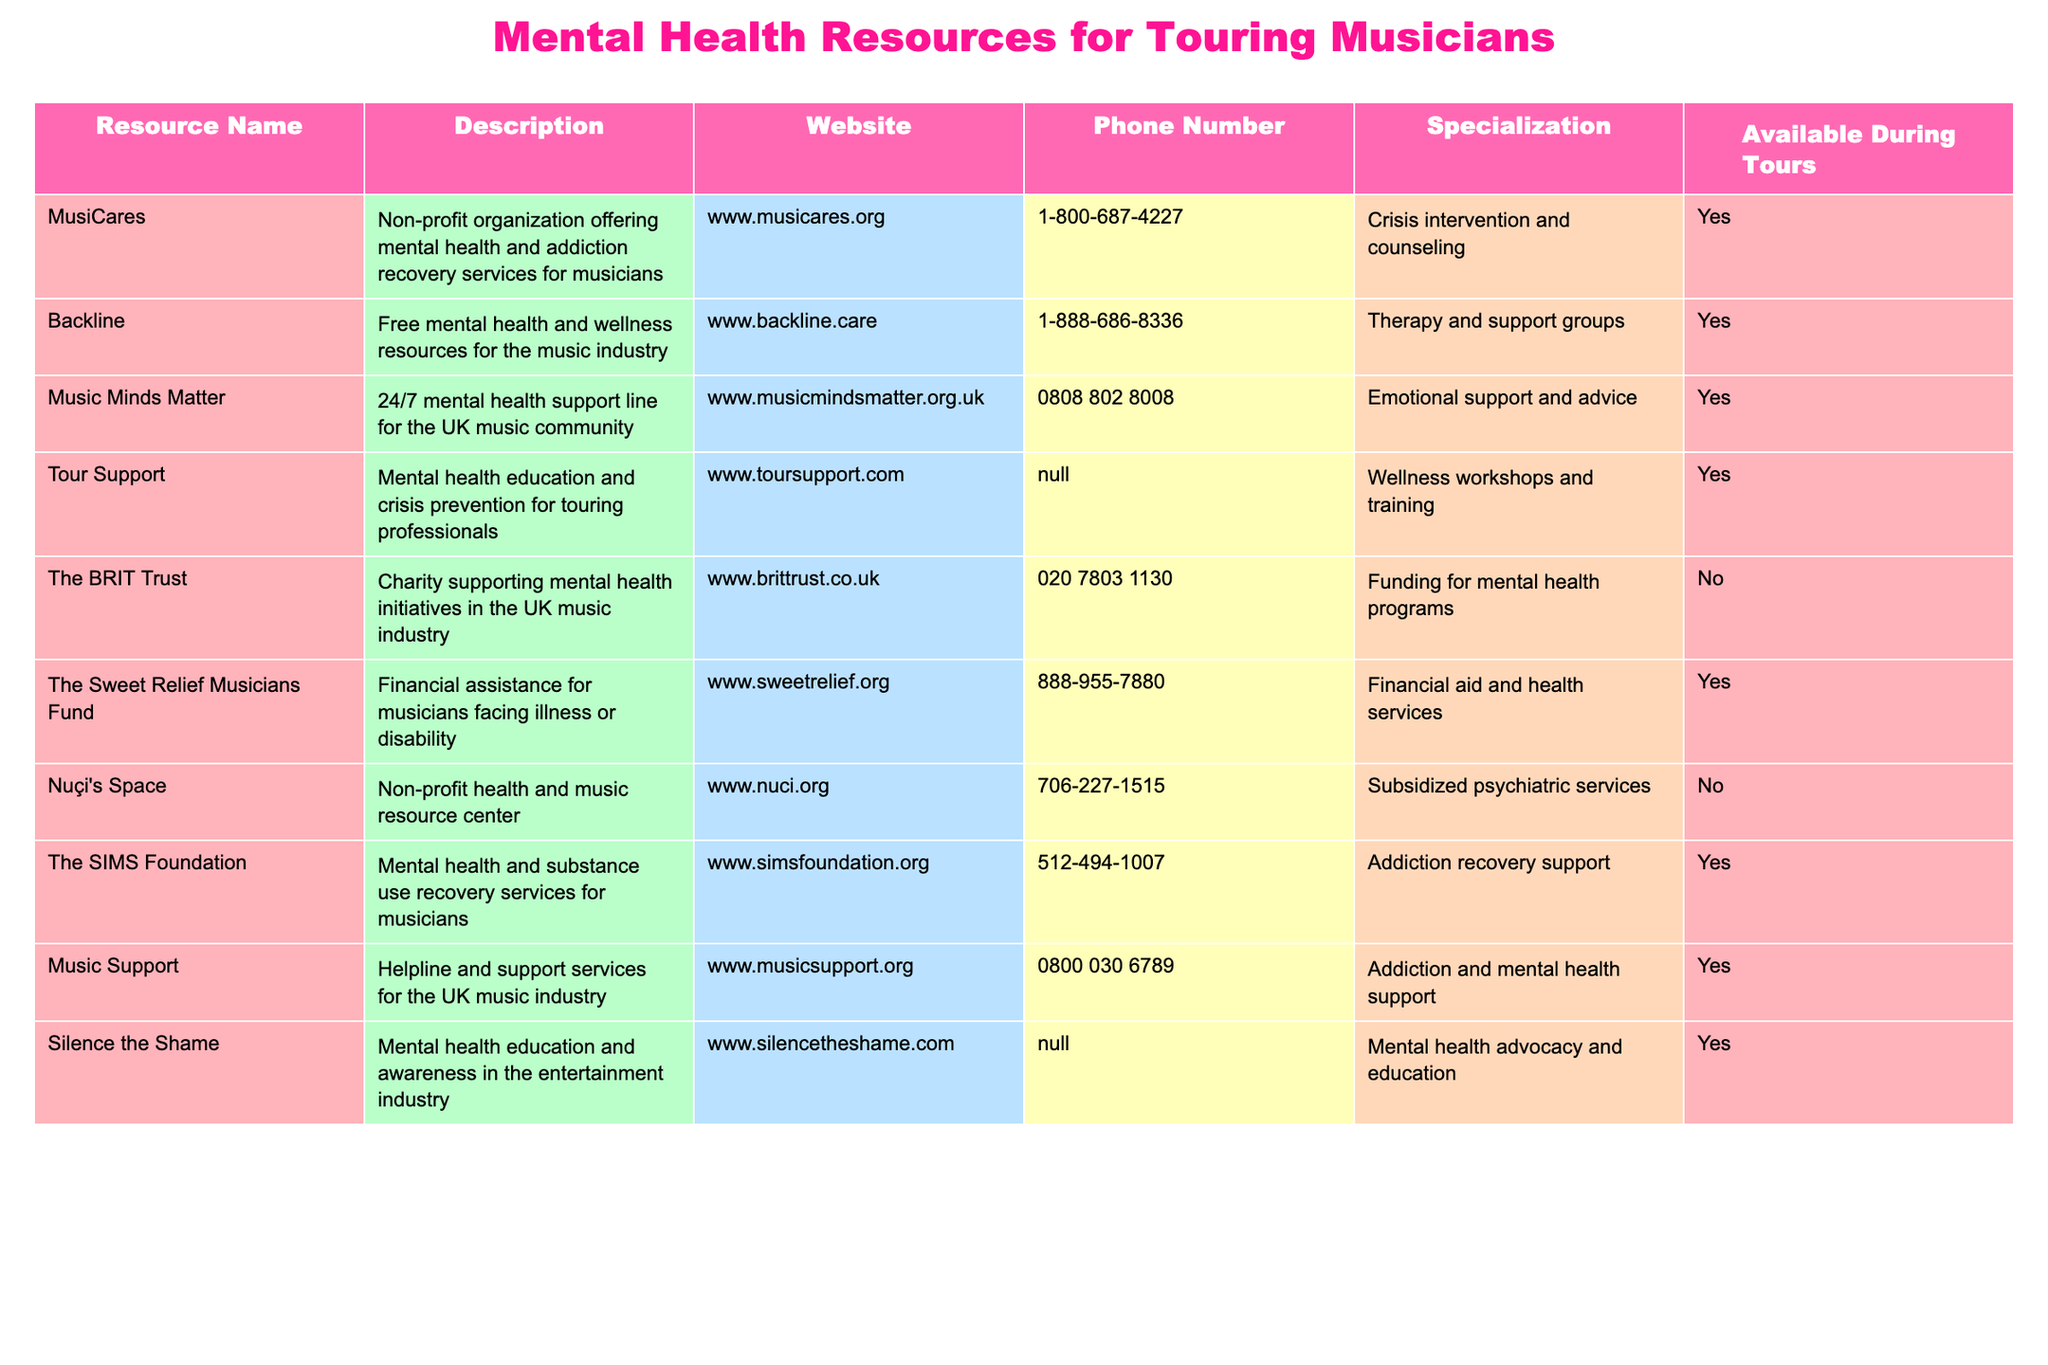What is the main specialization of the resource "Backline"? The table states that "Backline" specializes in therapy and support groups.
Answer: Therapy and support groups How many resources are available during tours? Looking at the "Available During Tours" column, we can count the entries marked "Yes". There are 8 resources available during tours.
Answer: 8 Is "The BRIT Trust" available during tours? The table indicates that "The BRIT Trust" is marked "No" under the "Available During Tours" column.
Answer: No Which resource provides a 24/7 support line specifically for the UK music community? Referring to the table, "Music Minds Matter" is noted as having a 24/7 mental health support line for the UK music community.
Answer: Music Minds Matter What are the two resources that provide financial aid for musicians? "The Sweet Relief Musicians Fund" and "The SIMS Foundation" are listed in the table as providing financial assistance.
Answer: The Sweet Relief Musicians Fund and The SIMS Foundation How many resources specialize in addiction recovery support? We can see from the "Specialization" column that both "The SIMS Foundation" and "Music Support" specialize in addiction recovery support. Therefore, there are 2 resources.
Answer: 2 Which resource has the phone number 1-800-687-4227? By looking at the phone numbers in the table, "MusiCares" is associated with the number 1-800-687-4227.
Answer: MusiCares If a touring musician needs emotional support, which resource should they contact? The table shows that "Music Minds Matter" offers emotional support and advice, making it the appropriate contact for emotional support.
Answer: Music Minds Matter What percentage of the resources listed provide support during tours? There are 10 total resources and 8 available during tours. The percentage is (8/10) * 100% = 80%.
Answer: 80% Are there any resources that provide wellness workshops and training? The table indicates that "Tour Support" offers wellness workshops and training as part of its specialization.
Answer: Yes 